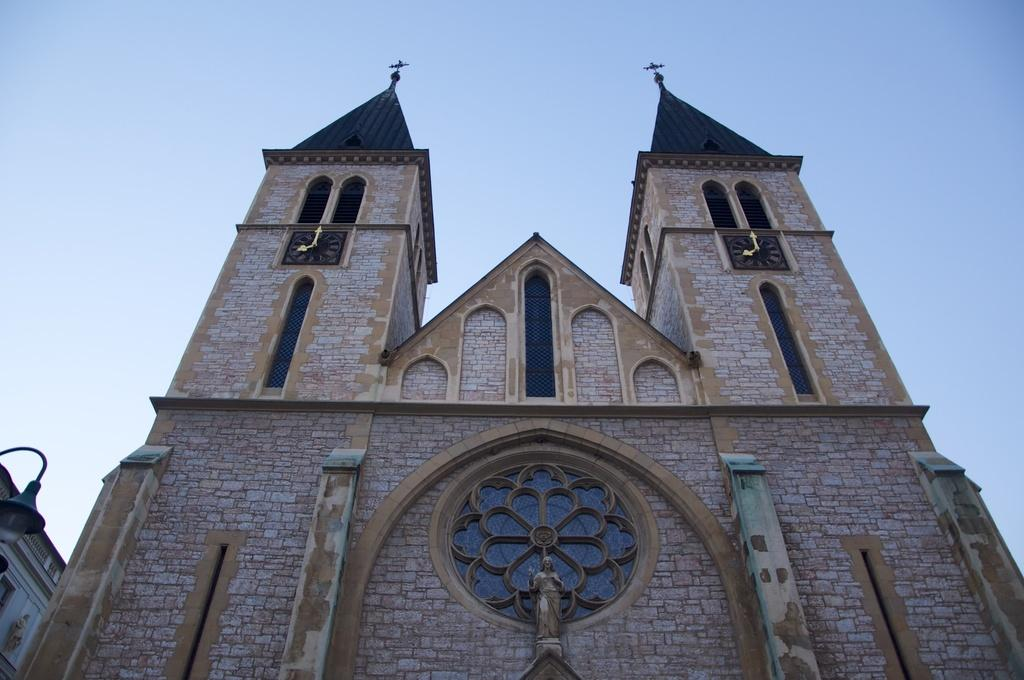What type of building is in the image? There is a church in the image. What can be seen in the background of the image? The sky is visible in the background of the image. What color is the hole in the church's roof in the image? There is no hole in the church's roof in the image, and therefore no color can be determined. 